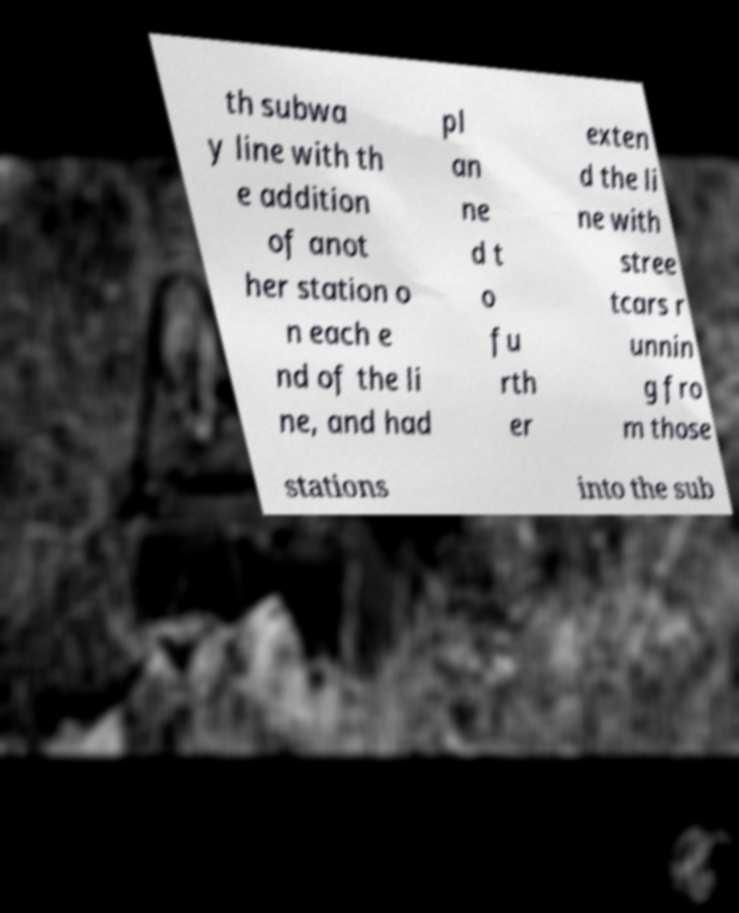Could you assist in decoding the text presented in this image and type it out clearly? th subwa y line with th e addition of anot her station o n each e nd of the li ne, and had pl an ne d t o fu rth er exten d the li ne with stree tcars r unnin g fro m those stations into the sub 